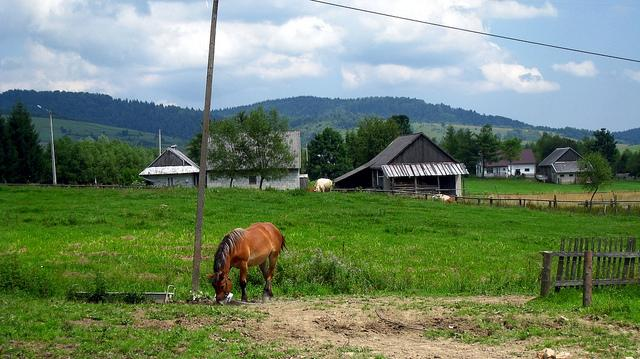What is the large pole near the horse supplying to the homes?

Choices:
A) electricity
B) milk
C) light
D) fruit electricity 